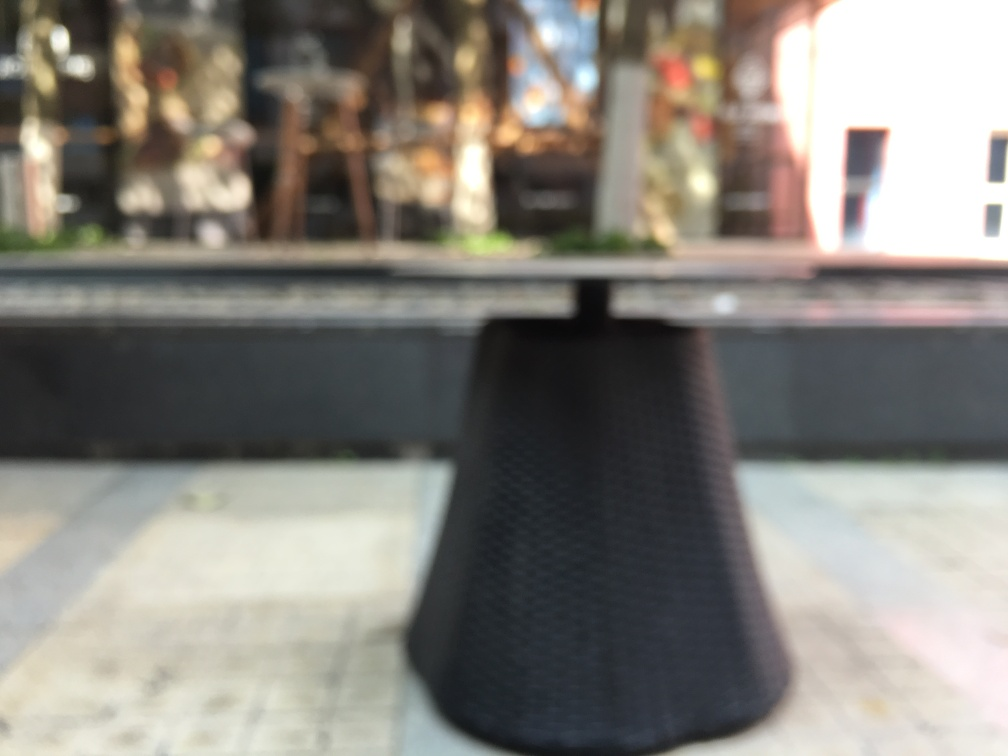How does the blurriness affect the ambience or mood of the image? The blurriness lends a dreamy, ethereal quality to the image that softens the overall appearance and creates a sense of mystery. It might evoke a feeling of nostalgia or a focus on the aesthetic of imperfection, known in Japanese culture as 'wabi-sabi', which appreciates the beauty in the flaws and transience of things. 